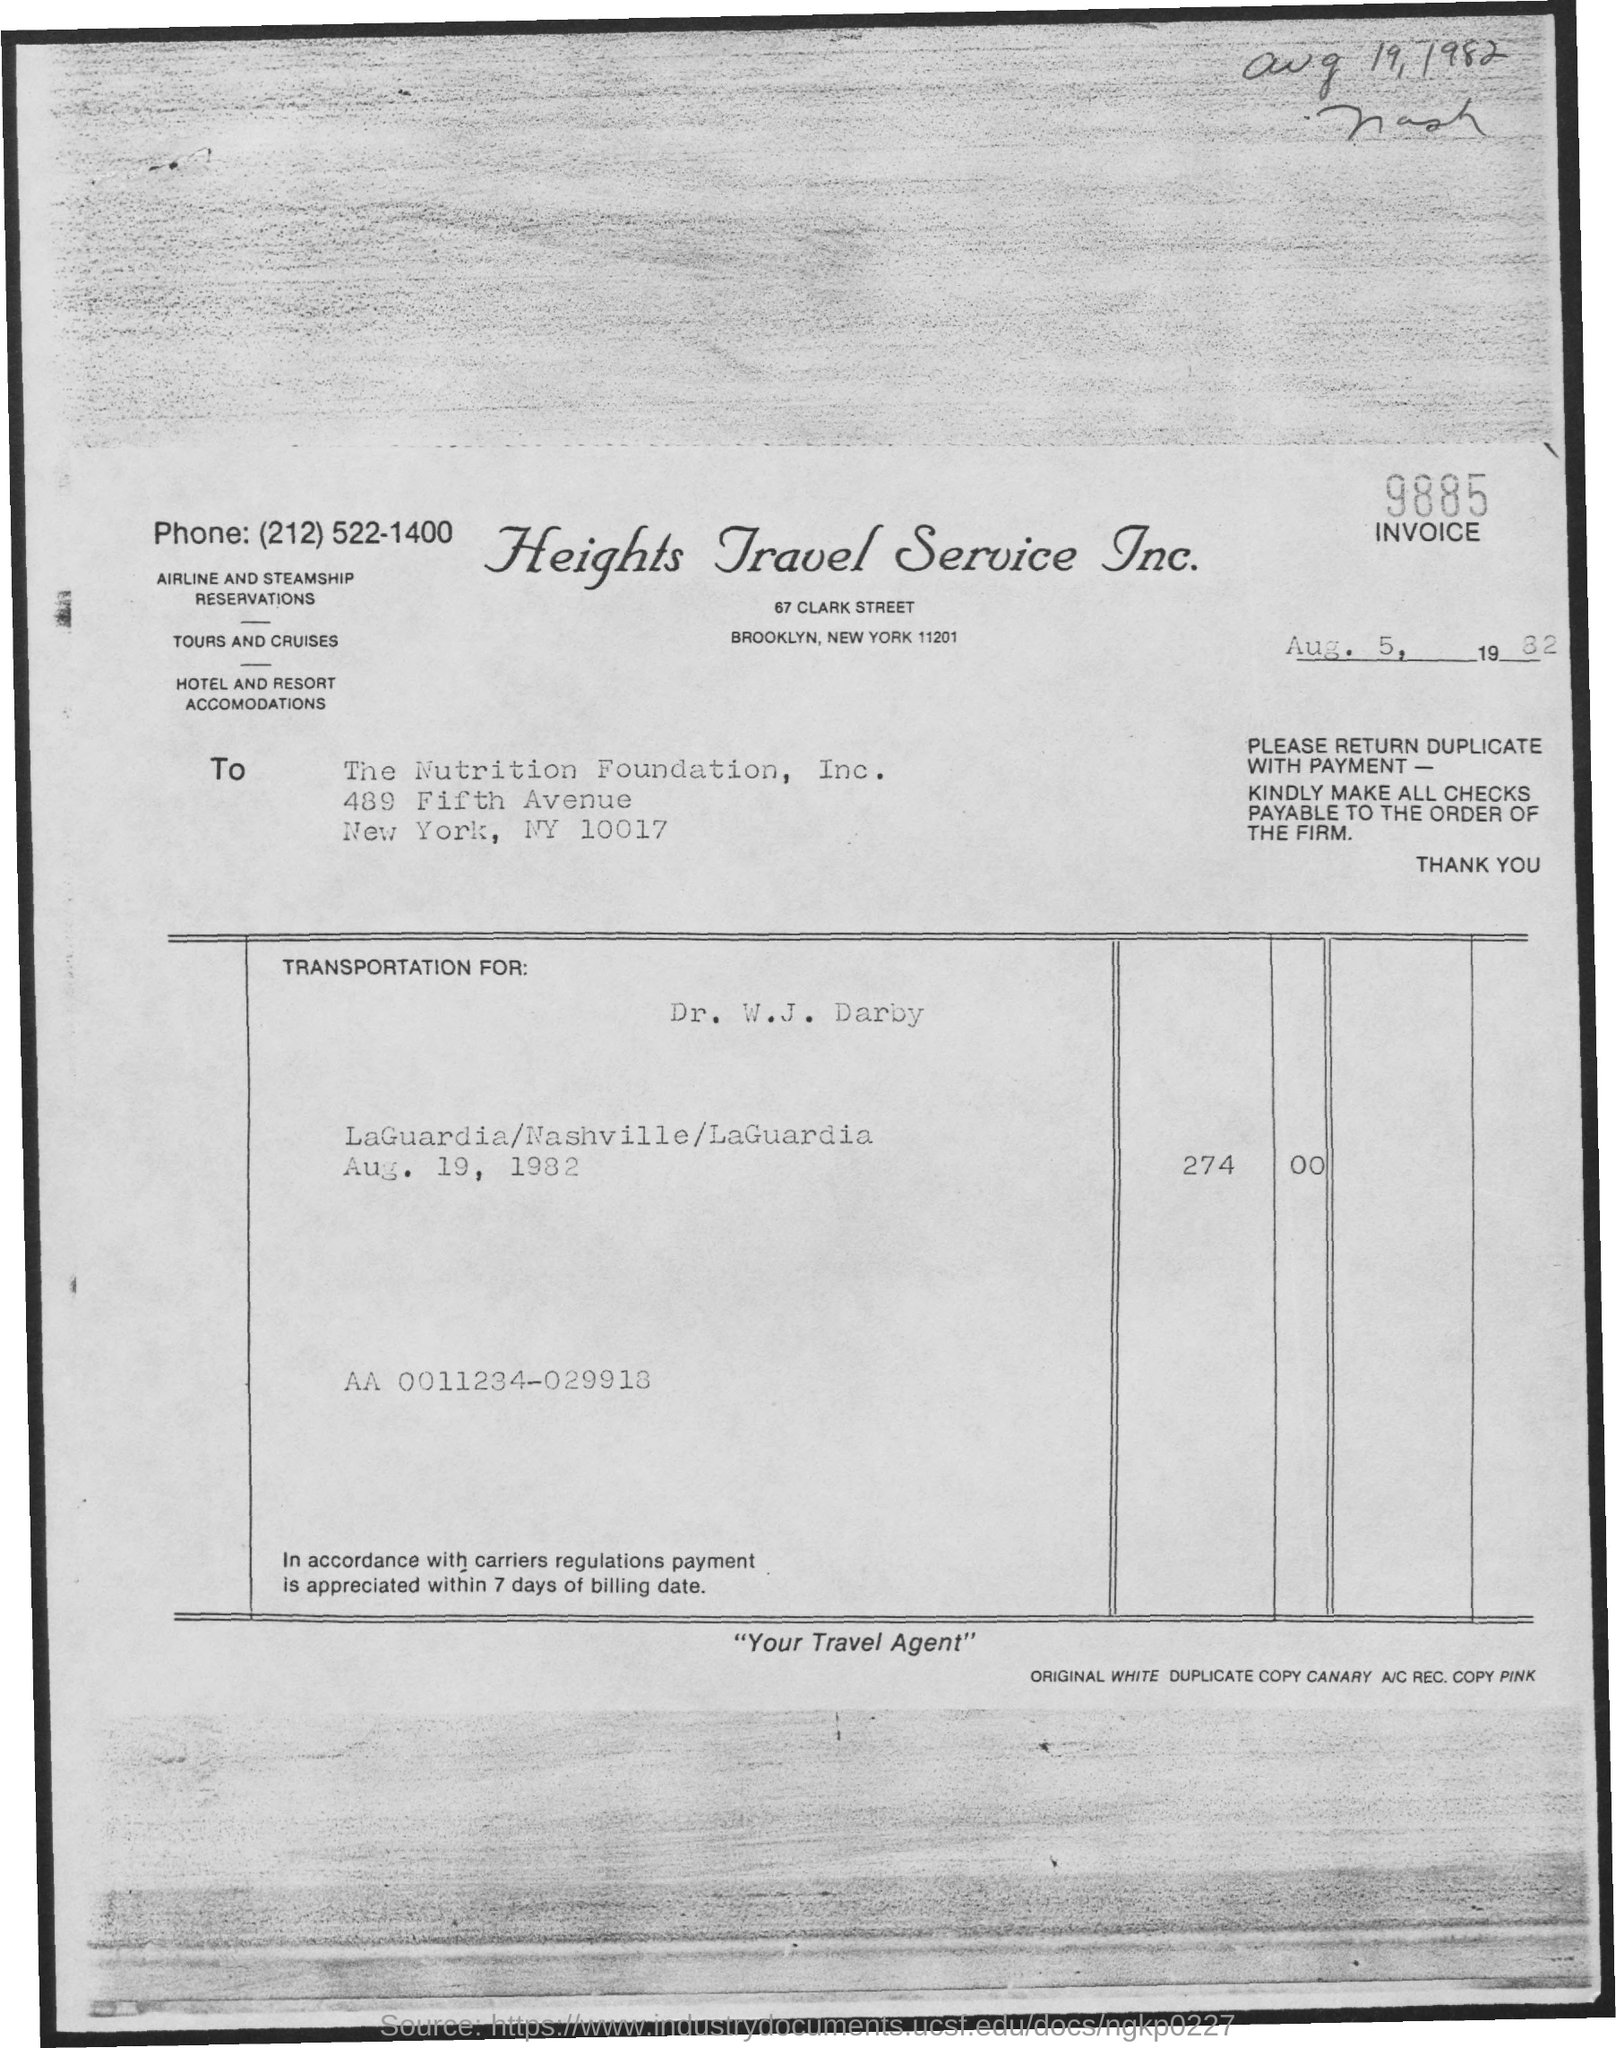What is the Invoice No. given in the document?
Provide a succinct answer. 9885. In which company's name, the invoice is issued?
Provide a succinct answer. The Nutrition Foundation, Inc. Which company has issued this invoice?
Provide a short and direct response. Heights Travel Service Inc. What is the issued date of the invoice?
Your answer should be compact. Aug. 5, 1982. 